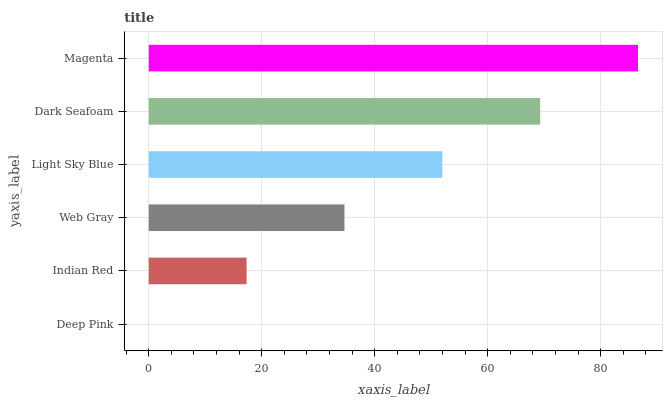Is Deep Pink the minimum?
Answer yes or no. Yes. Is Magenta the maximum?
Answer yes or no. Yes. Is Indian Red the minimum?
Answer yes or no. No. Is Indian Red the maximum?
Answer yes or no. No. Is Indian Red greater than Deep Pink?
Answer yes or no. Yes. Is Deep Pink less than Indian Red?
Answer yes or no. Yes. Is Deep Pink greater than Indian Red?
Answer yes or no. No. Is Indian Red less than Deep Pink?
Answer yes or no. No. Is Light Sky Blue the high median?
Answer yes or no. Yes. Is Web Gray the low median?
Answer yes or no. Yes. Is Web Gray the high median?
Answer yes or no. No. Is Light Sky Blue the low median?
Answer yes or no. No. 